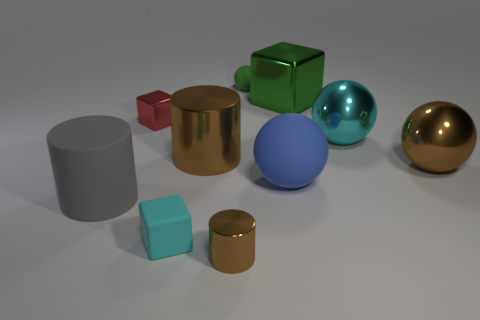Subtract 1 spheres. How many spheres are left? 3 Subtract all green blocks. Subtract all red cylinders. How many blocks are left? 2 Subtract all spheres. How many objects are left? 6 Subtract 1 cyan blocks. How many objects are left? 9 Subtract all small yellow metallic objects. Subtract all green cubes. How many objects are left? 9 Add 3 cyan things. How many cyan things are left? 5 Add 9 tiny blue shiny things. How many tiny blue shiny things exist? 9 